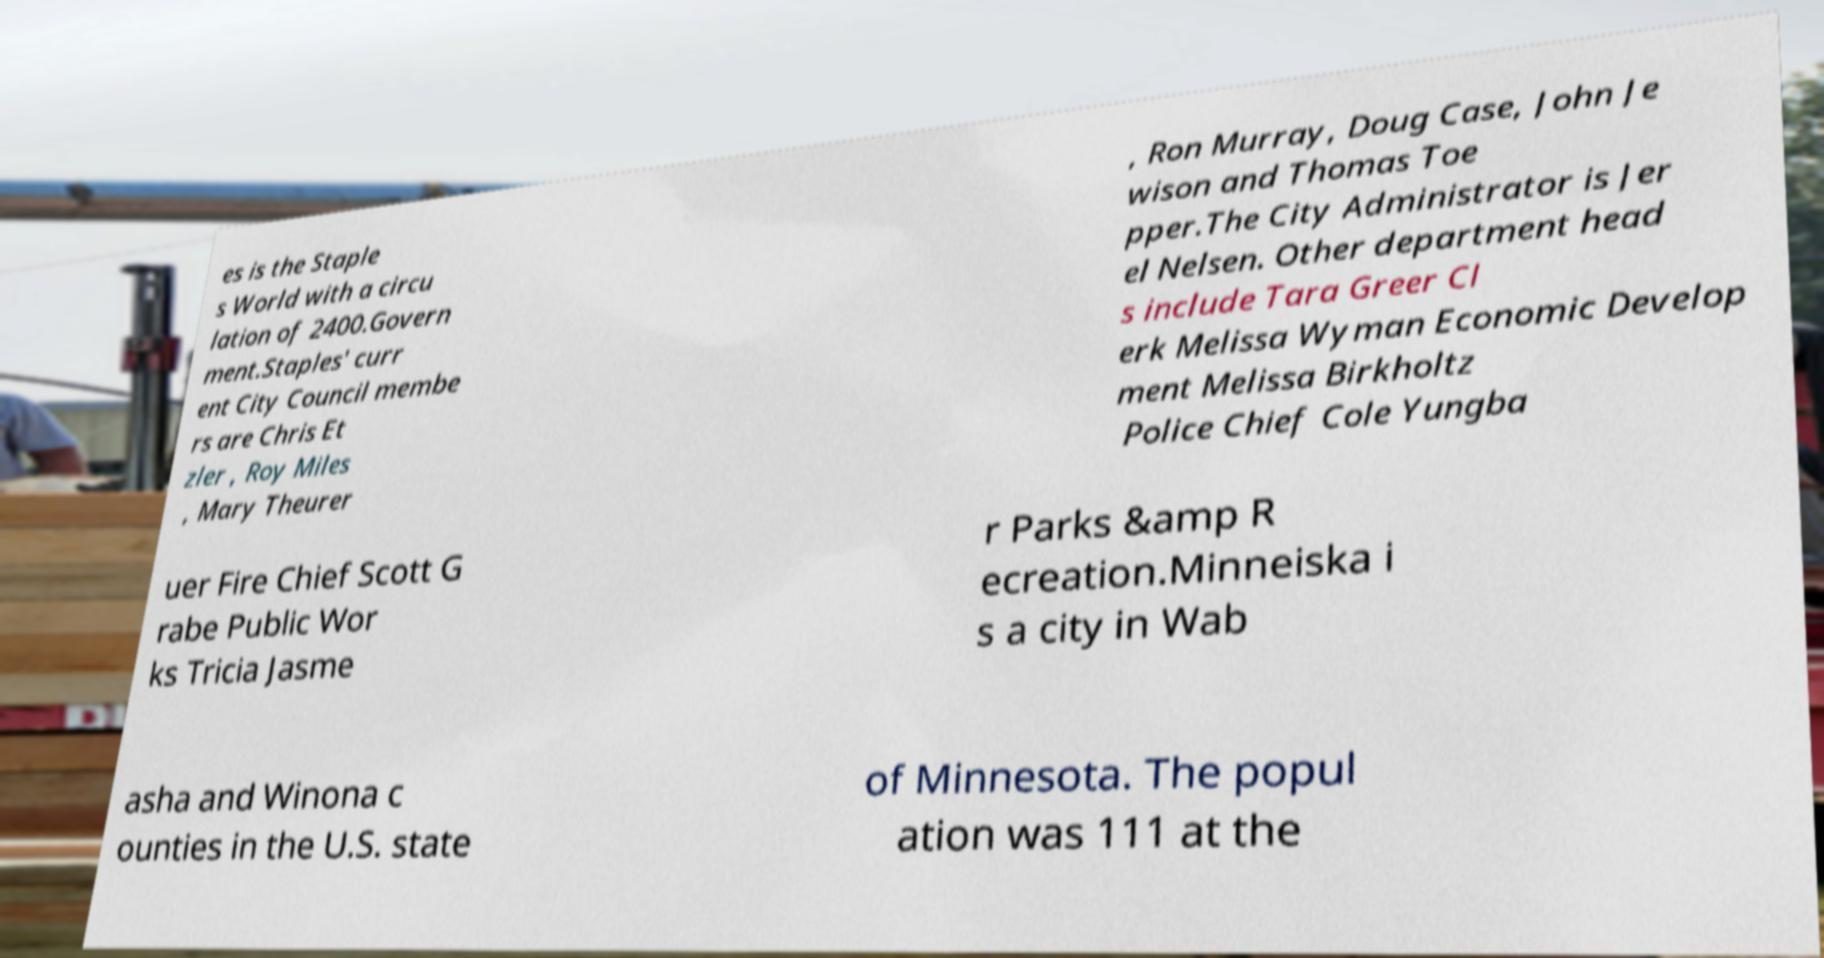Could you extract and type out the text from this image? es is the Staple s World with a circu lation of 2400.Govern ment.Staples' curr ent City Council membe rs are Chris Et zler , Roy Miles , Mary Theurer , Ron Murray, Doug Case, John Je wison and Thomas Toe pper.The City Administrator is Jer el Nelsen. Other department head s include Tara Greer Cl erk Melissa Wyman Economic Develop ment Melissa Birkholtz Police Chief Cole Yungba uer Fire Chief Scott G rabe Public Wor ks Tricia Jasme r Parks &amp R ecreation.Minneiska i s a city in Wab asha and Winona c ounties in the U.S. state of Minnesota. The popul ation was 111 at the 